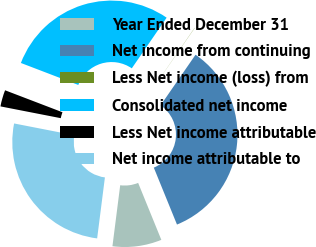Convert chart to OTSL. <chart><loc_0><loc_0><loc_500><loc_500><pie_chart><fcel>Year Ended December 31<fcel>Net income from continuing<fcel>Less Net income (loss) from<fcel>Consolidated net income<fcel>Less Net income attributable<fcel>Net income attributable to<nl><fcel>8.17%<fcel>34.22%<fcel>0.03%<fcel>28.77%<fcel>2.75%<fcel>26.05%<nl></chart> 